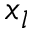Convert formula to latex. <formula><loc_0><loc_0><loc_500><loc_500>x _ { l }</formula> 